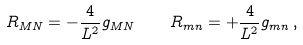Convert formula to latex. <formula><loc_0><loc_0><loc_500><loc_500>{ R _ { M N } = - \frac { 4 } { L ^ { 2 } } g _ { M N } \quad R _ { m n } = + \frac { 4 } { L ^ { 2 } } g _ { m n } \, , }</formula> 